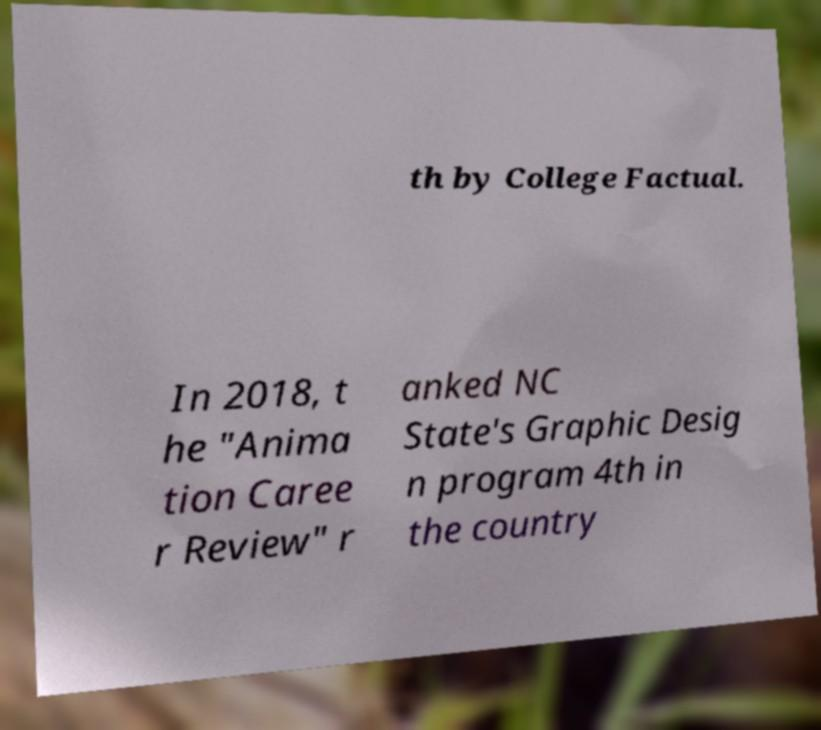Could you extract and type out the text from this image? th by College Factual. In 2018, t he "Anima tion Caree r Review" r anked NC State's Graphic Desig n program 4th in the country 